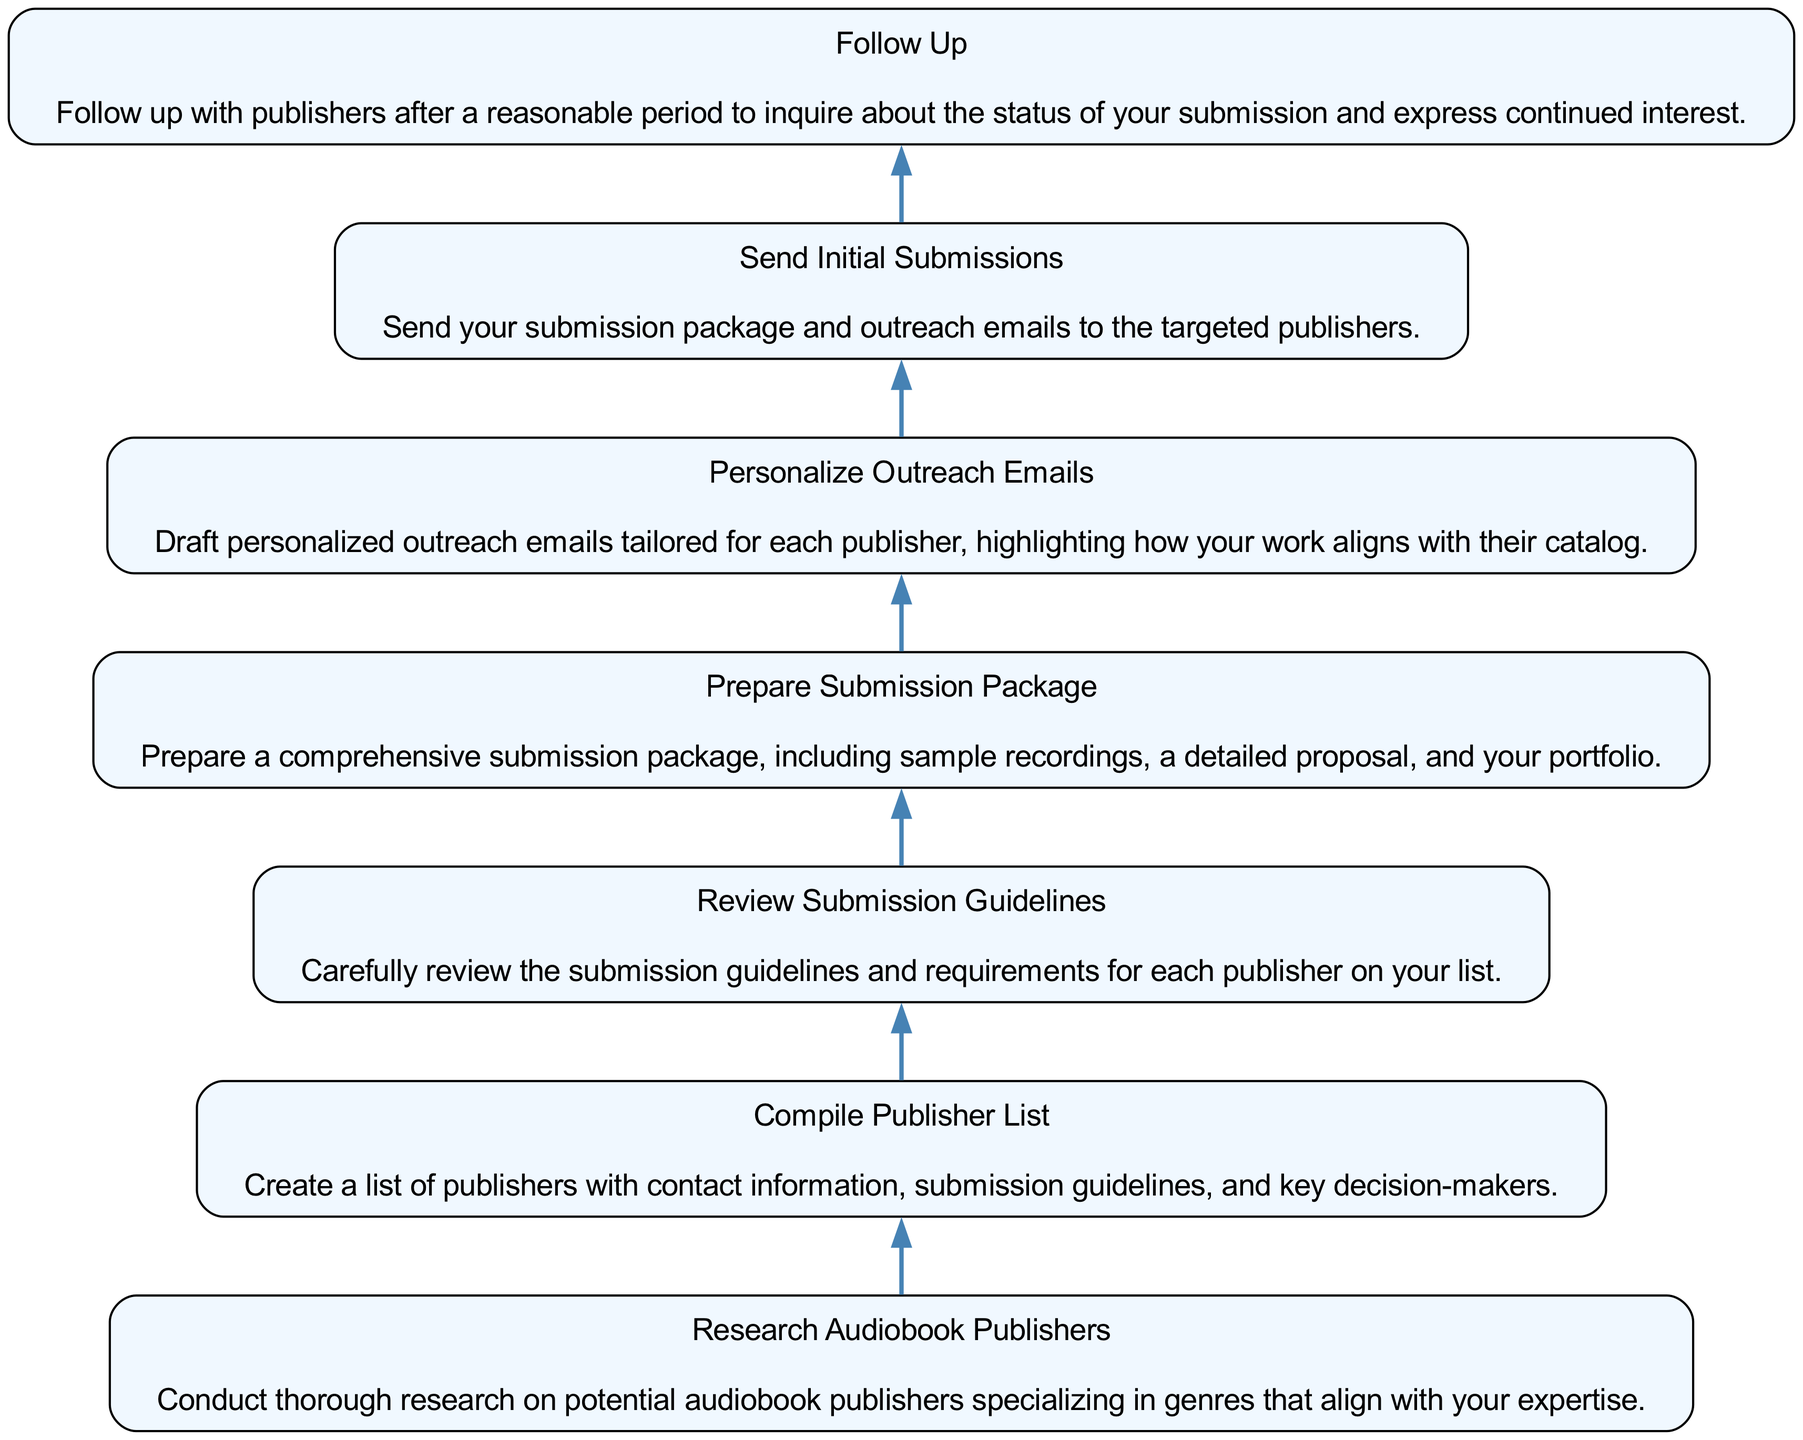What is the first step in the workflow? The first step listed in the workflow is "Research Audiobook Publishers." It's the starting point with no dependencies, meaning it can be initiated immediately to begin the process.
Answer: Research Audiobook Publishers How many nodes are present in the diagram? To determine the number of nodes, we count each distinct workflow element. There are seven elements total, each representing a step in the process from research to follow-up.
Answer: 7 What step comes after "Prepare Submission Package"? Based on the flow, the next step after "Prepare Submission Package" is "Personalize Outreach Emails." This follows logically as you would need your package ready before customizing your outreach.
Answer: Personalize Outreach Emails Which step requires "Compile Publisher List" to be completed first? The step that requires "Compile Publisher List" to be completed is "Review Submission Guidelines." This is because the guidelines can only be reviewed after assembling a list of publishers.
Answer: Review Submission Guidelines What is the last step in the workflow? The final step in the workflow is "Follow Up." It comes after sending initial submissions, indicating that you should check back with the publishers after a specified time.
Answer: Follow Up How many steps require personalization in their process? Only one step explicitly involves personalization, which is "Personalize Outreach Emails." It focuses on tailoring communication, indicating a need for customization in outreach efforts.
Answer: 1 Which step has the most dependencies? The step "Send Initial Submissions" has the most dependencies; it relies on the completion of all previous steps leading up to it, specifically "Personalize Outreach Emails."
Answer: Send Initial Submissions What do you need to review before preparing your submission package? You need to review the "Submission Guidelines." This step informs the contents and format of your submission package to ensure compliance with publisher requirements.
Answer: Review Submission Guidelines 